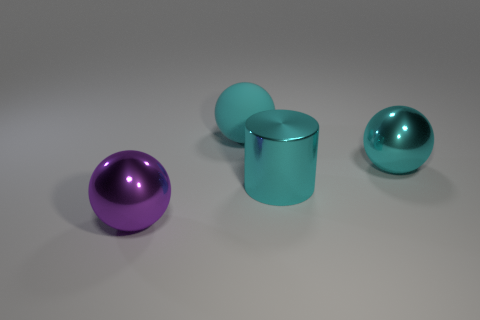There is a large cyan metal thing to the left of the cyan shiny sphere; what is its shape?
Give a very brief answer. Cylinder. There is a big ball that is behind the metal thing behind the metallic cylinder; is there a shiny thing to the left of it?
Keep it short and to the point. Yes. There is another purple object that is the same shape as the matte object; what material is it?
Offer a very short reply. Metal. How many cylinders are either cyan shiny things or purple objects?
Your answer should be very brief. 1. Is the size of the sphere that is behind the cyan shiny sphere the same as the cyan ball that is to the right of the big rubber ball?
Offer a terse response. Yes. What is the object that is behind the large metal sphere right of the large cyan cylinder made of?
Offer a terse response. Rubber. Is the number of balls behind the purple sphere less than the number of cyan spheres?
Your answer should be very brief. No. The big cyan thing that is the same material as the large cylinder is what shape?
Ensure brevity in your answer.  Sphere. What number of other things are there of the same shape as the purple thing?
Ensure brevity in your answer.  2. What number of purple objects are either big spheres or large rubber spheres?
Offer a terse response. 1. 